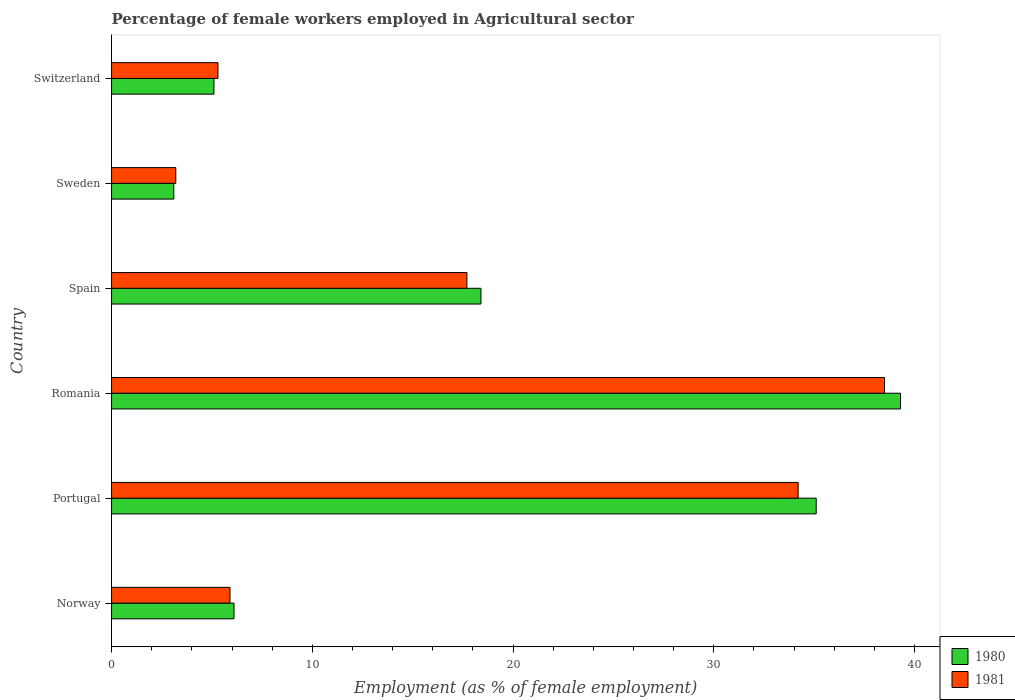Are the number of bars on each tick of the Y-axis equal?
Your response must be concise. Yes. What is the percentage of females employed in Agricultural sector in 1980 in Romania?
Give a very brief answer. 39.3. Across all countries, what is the maximum percentage of females employed in Agricultural sector in 1981?
Offer a terse response. 38.5. Across all countries, what is the minimum percentage of females employed in Agricultural sector in 1981?
Your answer should be compact. 3.2. In which country was the percentage of females employed in Agricultural sector in 1981 maximum?
Offer a very short reply. Romania. What is the total percentage of females employed in Agricultural sector in 1980 in the graph?
Offer a very short reply. 107.1. What is the difference between the percentage of females employed in Agricultural sector in 1981 in Portugal and that in Sweden?
Provide a succinct answer. 31. What is the difference between the percentage of females employed in Agricultural sector in 1981 in Portugal and the percentage of females employed in Agricultural sector in 1980 in Norway?
Keep it short and to the point. 28.1. What is the average percentage of females employed in Agricultural sector in 1981 per country?
Keep it short and to the point. 17.47. What is the difference between the percentage of females employed in Agricultural sector in 1980 and percentage of females employed in Agricultural sector in 1981 in Switzerland?
Ensure brevity in your answer.  -0.2. In how many countries, is the percentage of females employed in Agricultural sector in 1980 greater than 36 %?
Offer a very short reply. 1. What is the ratio of the percentage of females employed in Agricultural sector in 1980 in Spain to that in Switzerland?
Provide a short and direct response. 3.61. What is the difference between the highest and the second highest percentage of females employed in Agricultural sector in 1980?
Your answer should be very brief. 4.2. What is the difference between the highest and the lowest percentage of females employed in Agricultural sector in 1981?
Your response must be concise. 35.3. Is the sum of the percentage of females employed in Agricultural sector in 1980 in Romania and Switzerland greater than the maximum percentage of females employed in Agricultural sector in 1981 across all countries?
Provide a succinct answer. Yes. Are all the bars in the graph horizontal?
Make the answer very short. Yes. Are the values on the major ticks of X-axis written in scientific E-notation?
Make the answer very short. No. Does the graph contain grids?
Keep it short and to the point. No. How many legend labels are there?
Make the answer very short. 2. What is the title of the graph?
Your answer should be very brief. Percentage of female workers employed in Agricultural sector. Does "1988" appear as one of the legend labels in the graph?
Offer a very short reply. No. What is the label or title of the X-axis?
Your answer should be compact. Employment (as % of female employment). What is the label or title of the Y-axis?
Your answer should be very brief. Country. What is the Employment (as % of female employment) in 1980 in Norway?
Provide a succinct answer. 6.1. What is the Employment (as % of female employment) in 1981 in Norway?
Offer a very short reply. 5.9. What is the Employment (as % of female employment) in 1980 in Portugal?
Your response must be concise. 35.1. What is the Employment (as % of female employment) of 1981 in Portugal?
Offer a very short reply. 34.2. What is the Employment (as % of female employment) of 1980 in Romania?
Offer a terse response. 39.3. What is the Employment (as % of female employment) of 1981 in Romania?
Your answer should be very brief. 38.5. What is the Employment (as % of female employment) of 1980 in Spain?
Ensure brevity in your answer.  18.4. What is the Employment (as % of female employment) in 1981 in Spain?
Keep it short and to the point. 17.7. What is the Employment (as % of female employment) of 1980 in Sweden?
Your answer should be compact. 3.1. What is the Employment (as % of female employment) of 1981 in Sweden?
Provide a short and direct response. 3.2. What is the Employment (as % of female employment) of 1980 in Switzerland?
Make the answer very short. 5.1. What is the Employment (as % of female employment) in 1981 in Switzerland?
Your response must be concise. 5.3. Across all countries, what is the maximum Employment (as % of female employment) of 1980?
Your answer should be compact. 39.3. Across all countries, what is the maximum Employment (as % of female employment) in 1981?
Keep it short and to the point. 38.5. Across all countries, what is the minimum Employment (as % of female employment) of 1980?
Your response must be concise. 3.1. Across all countries, what is the minimum Employment (as % of female employment) of 1981?
Ensure brevity in your answer.  3.2. What is the total Employment (as % of female employment) of 1980 in the graph?
Your response must be concise. 107.1. What is the total Employment (as % of female employment) in 1981 in the graph?
Your response must be concise. 104.8. What is the difference between the Employment (as % of female employment) in 1981 in Norway and that in Portugal?
Offer a very short reply. -28.3. What is the difference between the Employment (as % of female employment) of 1980 in Norway and that in Romania?
Keep it short and to the point. -33.2. What is the difference between the Employment (as % of female employment) in 1981 in Norway and that in Romania?
Make the answer very short. -32.6. What is the difference between the Employment (as % of female employment) of 1980 in Norway and that in Spain?
Your response must be concise. -12.3. What is the difference between the Employment (as % of female employment) of 1980 in Norway and that in Sweden?
Ensure brevity in your answer.  3. What is the difference between the Employment (as % of female employment) of 1981 in Norway and that in Switzerland?
Make the answer very short. 0.6. What is the difference between the Employment (as % of female employment) in 1980 in Portugal and that in Spain?
Provide a succinct answer. 16.7. What is the difference between the Employment (as % of female employment) in 1981 in Portugal and that in Spain?
Your answer should be compact. 16.5. What is the difference between the Employment (as % of female employment) of 1980 in Portugal and that in Sweden?
Make the answer very short. 32. What is the difference between the Employment (as % of female employment) in 1981 in Portugal and that in Sweden?
Your answer should be very brief. 31. What is the difference between the Employment (as % of female employment) in 1981 in Portugal and that in Switzerland?
Offer a terse response. 28.9. What is the difference between the Employment (as % of female employment) in 1980 in Romania and that in Spain?
Keep it short and to the point. 20.9. What is the difference between the Employment (as % of female employment) of 1981 in Romania and that in Spain?
Provide a short and direct response. 20.8. What is the difference between the Employment (as % of female employment) of 1980 in Romania and that in Sweden?
Offer a terse response. 36.2. What is the difference between the Employment (as % of female employment) in 1981 in Romania and that in Sweden?
Provide a short and direct response. 35.3. What is the difference between the Employment (as % of female employment) of 1980 in Romania and that in Switzerland?
Give a very brief answer. 34.2. What is the difference between the Employment (as % of female employment) of 1981 in Romania and that in Switzerland?
Your answer should be compact. 33.2. What is the difference between the Employment (as % of female employment) in 1980 in Spain and that in Sweden?
Provide a short and direct response. 15.3. What is the difference between the Employment (as % of female employment) of 1980 in Spain and that in Switzerland?
Give a very brief answer. 13.3. What is the difference between the Employment (as % of female employment) in 1980 in Sweden and that in Switzerland?
Ensure brevity in your answer.  -2. What is the difference between the Employment (as % of female employment) of 1980 in Norway and the Employment (as % of female employment) of 1981 in Portugal?
Make the answer very short. -28.1. What is the difference between the Employment (as % of female employment) in 1980 in Norway and the Employment (as % of female employment) in 1981 in Romania?
Offer a terse response. -32.4. What is the difference between the Employment (as % of female employment) of 1980 in Portugal and the Employment (as % of female employment) of 1981 in Romania?
Ensure brevity in your answer.  -3.4. What is the difference between the Employment (as % of female employment) of 1980 in Portugal and the Employment (as % of female employment) of 1981 in Sweden?
Keep it short and to the point. 31.9. What is the difference between the Employment (as % of female employment) in 1980 in Portugal and the Employment (as % of female employment) in 1981 in Switzerland?
Your answer should be very brief. 29.8. What is the difference between the Employment (as % of female employment) of 1980 in Romania and the Employment (as % of female employment) of 1981 in Spain?
Your answer should be very brief. 21.6. What is the difference between the Employment (as % of female employment) of 1980 in Romania and the Employment (as % of female employment) of 1981 in Sweden?
Your answer should be compact. 36.1. What is the difference between the Employment (as % of female employment) in 1980 in Spain and the Employment (as % of female employment) in 1981 in Sweden?
Your response must be concise. 15.2. What is the difference between the Employment (as % of female employment) of 1980 in Sweden and the Employment (as % of female employment) of 1981 in Switzerland?
Offer a terse response. -2.2. What is the average Employment (as % of female employment) of 1980 per country?
Keep it short and to the point. 17.85. What is the average Employment (as % of female employment) in 1981 per country?
Ensure brevity in your answer.  17.47. What is the difference between the Employment (as % of female employment) of 1980 and Employment (as % of female employment) of 1981 in Norway?
Offer a terse response. 0.2. What is the difference between the Employment (as % of female employment) in 1980 and Employment (as % of female employment) in 1981 in Portugal?
Offer a very short reply. 0.9. What is the difference between the Employment (as % of female employment) of 1980 and Employment (as % of female employment) of 1981 in Romania?
Keep it short and to the point. 0.8. What is the difference between the Employment (as % of female employment) in 1980 and Employment (as % of female employment) in 1981 in Switzerland?
Give a very brief answer. -0.2. What is the ratio of the Employment (as % of female employment) of 1980 in Norway to that in Portugal?
Provide a short and direct response. 0.17. What is the ratio of the Employment (as % of female employment) in 1981 in Norway to that in Portugal?
Provide a succinct answer. 0.17. What is the ratio of the Employment (as % of female employment) in 1980 in Norway to that in Romania?
Provide a succinct answer. 0.16. What is the ratio of the Employment (as % of female employment) of 1981 in Norway to that in Romania?
Provide a succinct answer. 0.15. What is the ratio of the Employment (as % of female employment) in 1980 in Norway to that in Spain?
Your answer should be very brief. 0.33. What is the ratio of the Employment (as % of female employment) of 1980 in Norway to that in Sweden?
Your answer should be very brief. 1.97. What is the ratio of the Employment (as % of female employment) of 1981 in Norway to that in Sweden?
Make the answer very short. 1.84. What is the ratio of the Employment (as % of female employment) of 1980 in Norway to that in Switzerland?
Your answer should be very brief. 1.2. What is the ratio of the Employment (as % of female employment) of 1981 in Norway to that in Switzerland?
Ensure brevity in your answer.  1.11. What is the ratio of the Employment (as % of female employment) in 1980 in Portugal to that in Romania?
Offer a terse response. 0.89. What is the ratio of the Employment (as % of female employment) in 1981 in Portugal to that in Romania?
Offer a very short reply. 0.89. What is the ratio of the Employment (as % of female employment) of 1980 in Portugal to that in Spain?
Offer a very short reply. 1.91. What is the ratio of the Employment (as % of female employment) of 1981 in Portugal to that in Spain?
Make the answer very short. 1.93. What is the ratio of the Employment (as % of female employment) of 1980 in Portugal to that in Sweden?
Offer a terse response. 11.32. What is the ratio of the Employment (as % of female employment) of 1981 in Portugal to that in Sweden?
Your answer should be compact. 10.69. What is the ratio of the Employment (as % of female employment) in 1980 in Portugal to that in Switzerland?
Offer a terse response. 6.88. What is the ratio of the Employment (as % of female employment) of 1981 in Portugal to that in Switzerland?
Provide a short and direct response. 6.45. What is the ratio of the Employment (as % of female employment) in 1980 in Romania to that in Spain?
Ensure brevity in your answer.  2.14. What is the ratio of the Employment (as % of female employment) of 1981 in Romania to that in Spain?
Offer a terse response. 2.18. What is the ratio of the Employment (as % of female employment) in 1980 in Romania to that in Sweden?
Your answer should be compact. 12.68. What is the ratio of the Employment (as % of female employment) in 1981 in Romania to that in Sweden?
Make the answer very short. 12.03. What is the ratio of the Employment (as % of female employment) in 1980 in Romania to that in Switzerland?
Offer a very short reply. 7.71. What is the ratio of the Employment (as % of female employment) of 1981 in Romania to that in Switzerland?
Your response must be concise. 7.26. What is the ratio of the Employment (as % of female employment) in 1980 in Spain to that in Sweden?
Ensure brevity in your answer.  5.94. What is the ratio of the Employment (as % of female employment) of 1981 in Spain to that in Sweden?
Your answer should be very brief. 5.53. What is the ratio of the Employment (as % of female employment) of 1980 in Spain to that in Switzerland?
Provide a short and direct response. 3.61. What is the ratio of the Employment (as % of female employment) in 1981 in Spain to that in Switzerland?
Offer a terse response. 3.34. What is the ratio of the Employment (as % of female employment) in 1980 in Sweden to that in Switzerland?
Offer a very short reply. 0.61. What is the ratio of the Employment (as % of female employment) of 1981 in Sweden to that in Switzerland?
Your answer should be very brief. 0.6. What is the difference between the highest and the second highest Employment (as % of female employment) of 1981?
Ensure brevity in your answer.  4.3. What is the difference between the highest and the lowest Employment (as % of female employment) in 1980?
Make the answer very short. 36.2. What is the difference between the highest and the lowest Employment (as % of female employment) in 1981?
Offer a terse response. 35.3. 